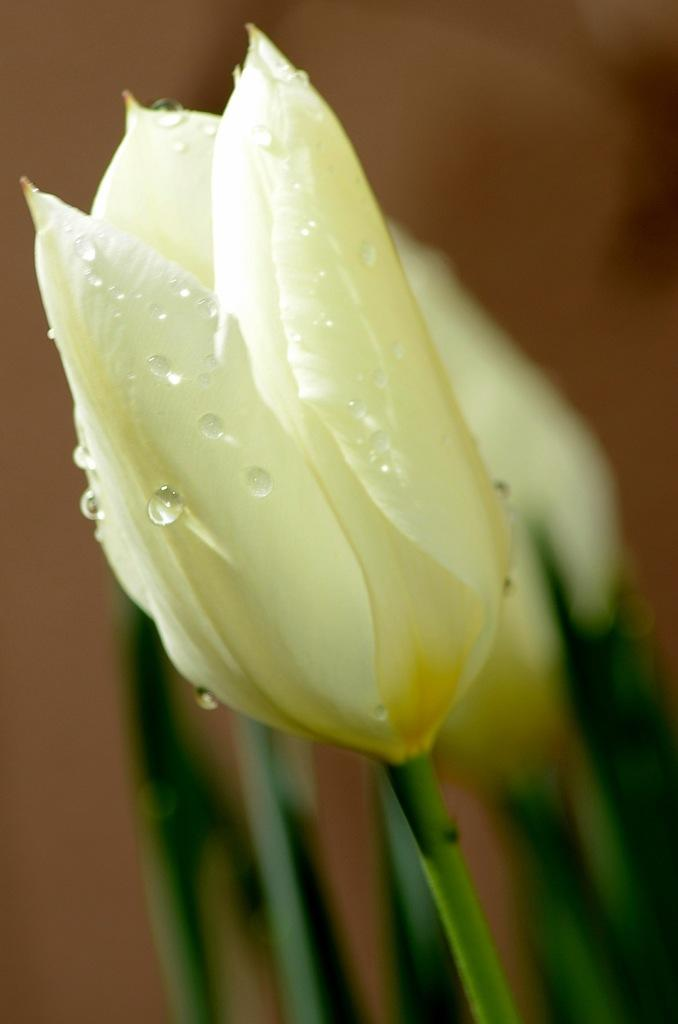What type of living organisms can be seen in the image? There are flowers in the image. Where are the flowers located? The flowers are on plants. What can be observed on the surface of the flowers? There are water droplets on the flowers. How would you describe the background of the image? The background of the image is blurry. What day of the week is indicated on the calendar in the image? There is no calendar present in the image. What thought might the flowers be having in the image? Flowers do not have thoughts, as they are plants and not capable of thinking. 